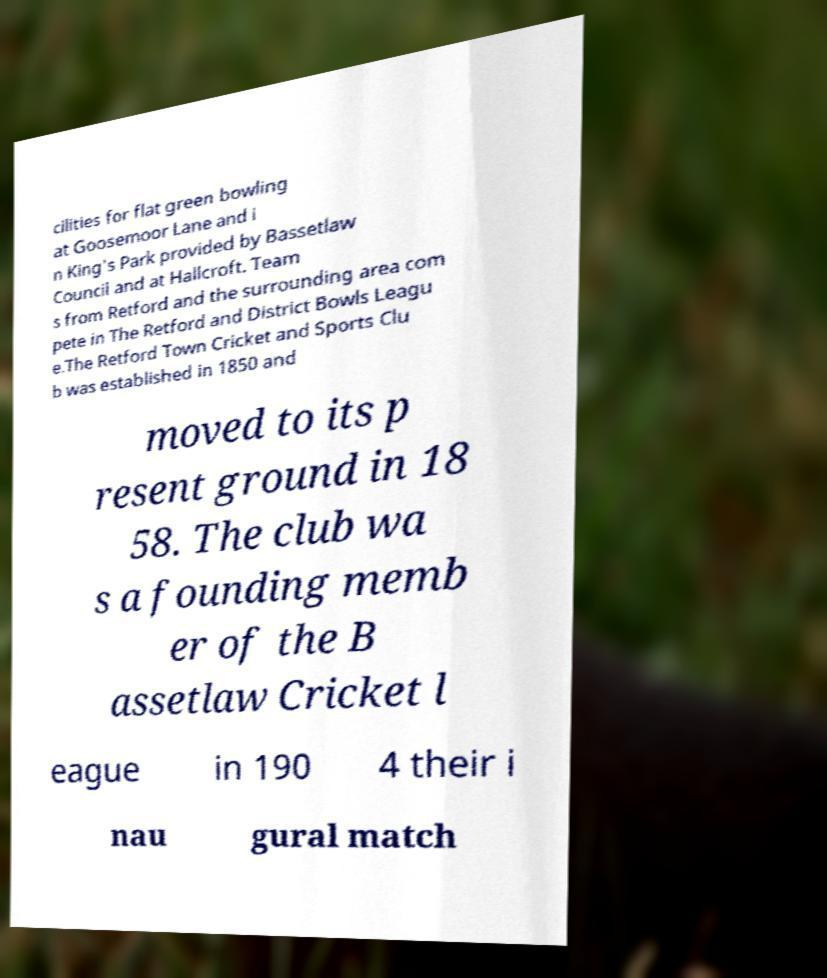Can you read and provide the text displayed in the image?This photo seems to have some interesting text. Can you extract and type it out for me? cilities for flat green bowling at Goosemoor Lane and i n King's Park provided by Bassetlaw Council and at Hallcroft. Team s from Retford and the surrounding area com pete in The Retford and District Bowls Leagu e.The Retford Town Cricket and Sports Clu b was established in 1850 and moved to its p resent ground in 18 58. The club wa s a founding memb er of the B assetlaw Cricket l eague in 190 4 their i nau gural match 